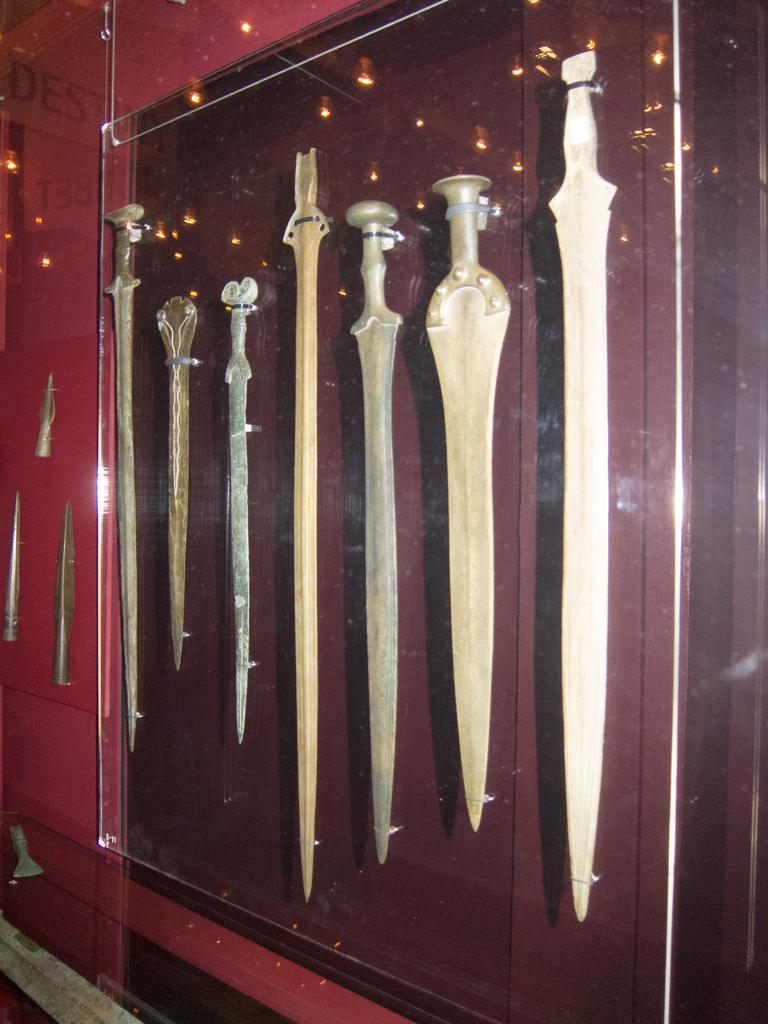Can you describe this image briefly? In this picture I can see there are some swords placed here and there is a glass covered on the swords. 